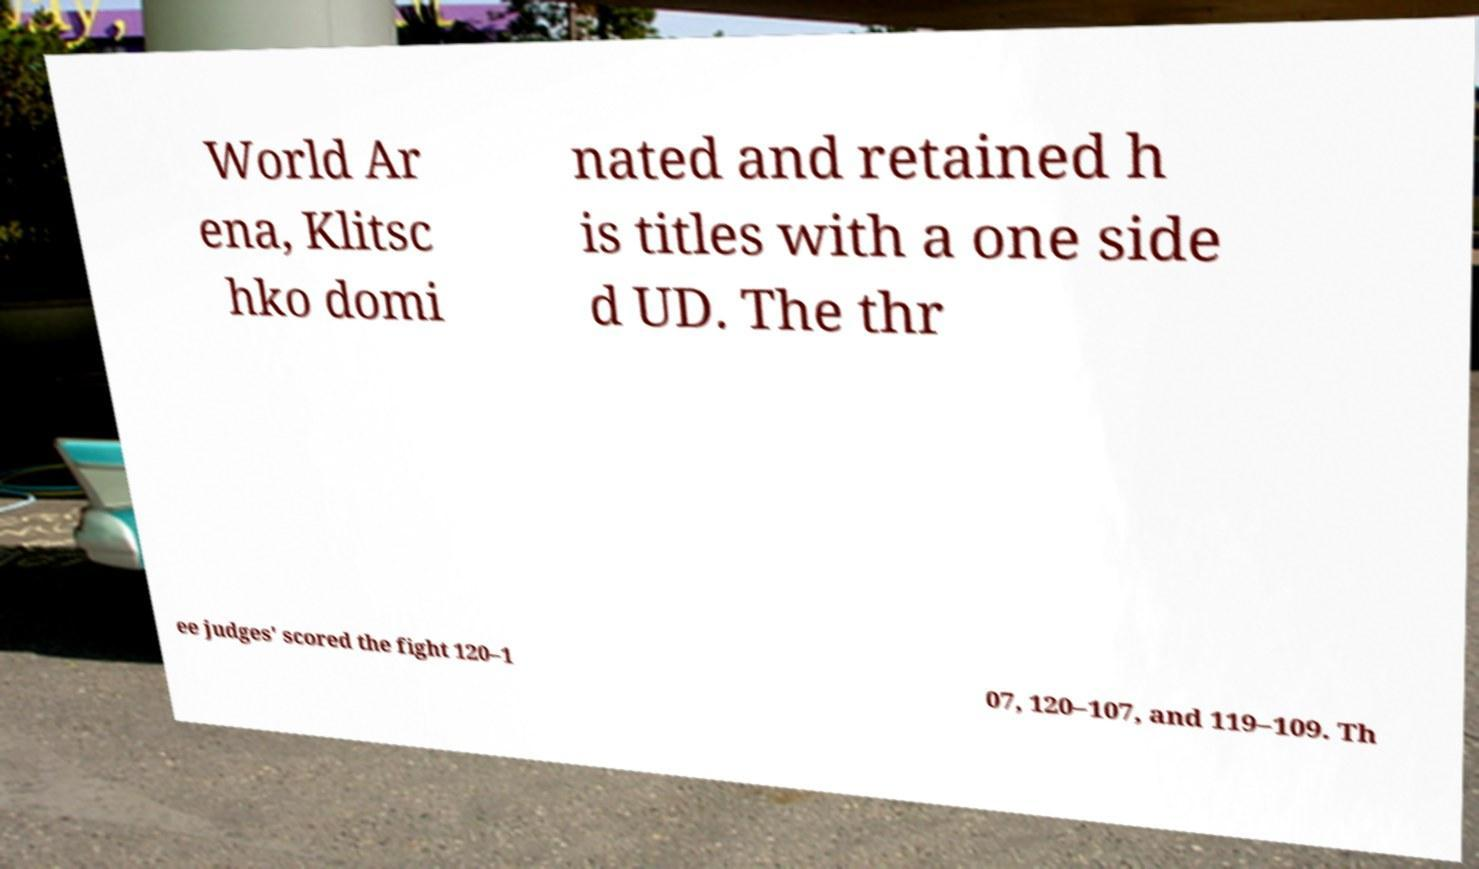Please read and relay the text visible in this image. What does it say? World Ar ena, Klitsc hko domi nated and retained h is titles with a one side d UD. The thr ee judges' scored the fight 120–1 07, 120–107, and 119–109. Th 